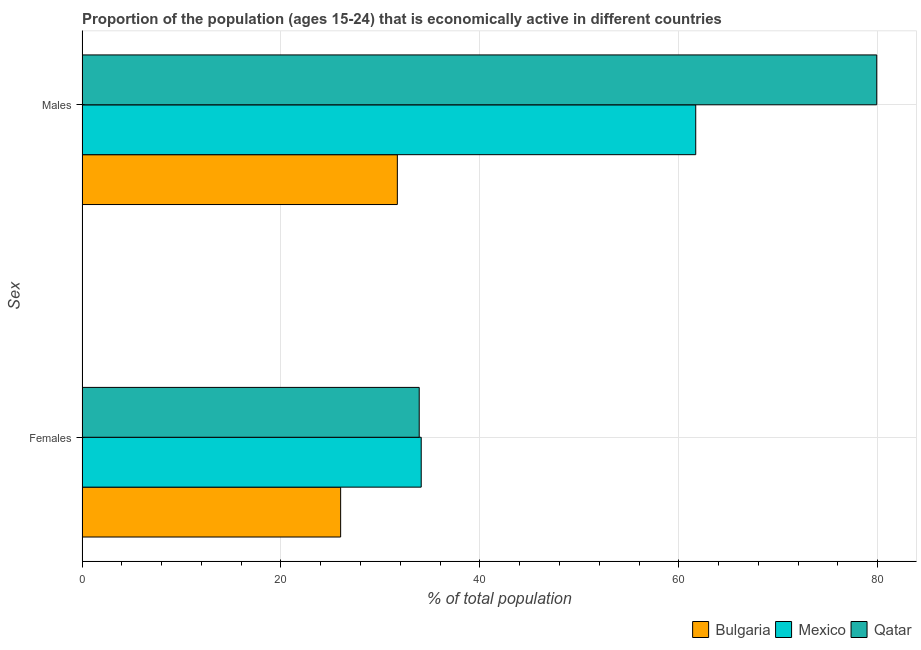How many groups of bars are there?
Give a very brief answer. 2. Are the number of bars on each tick of the Y-axis equal?
Offer a very short reply. Yes. What is the label of the 1st group of bars from the top?
Your response must be concise. Males. What is the percentage of economically active male population in Bulgaria?
Provide a short and direct response. 31.7. Across all countries, what is the maximum percentage of economically active female population?
Your answer should be very brief. 34.1. In which country was the percentage of economically active male population maximum?
Give a very brief answer. Qatar. In which country was the percentage of economically active male population minimum?
Your answer should be very brief. Bulgaria. What is the total percentage of economically active male population in the graph?
Your answer should be very brief. 173.3. What is the difference between the percentage of economically active female population in Bulgaria and that in Mexico?
Make the answer very short. -8.1. What is the difference between the percentage of economically active female population in Qatar and the percentage of economically active male population in Mexico?
Your answer should be compact. -27.8. What is the average percentage of economically active male population per country?
Keep it short and to the point. 57.77. What is the difference between the percentage of economically active female population and percentage of economically active male population in Bulgaria?
Provide a succinct answer. -5.7. What is the ratio of the percentage of economically active male population in Qatar to that in Mexico?
Ensure brevity in your answer.  1.29. What does the 2nd bar from the top in Females represents?
Make the answer very short. Mexico. What does the 3rd bar from the bottom in Males represents?
Give a very brief answer. Qatar. How many bars are there?
Your answer should be compact. 6. Are the values on the major ticks of X-axis written in scientific E-notation?
Keep it short and to the point. No. Does the graph contain any zero values?
Your answer should be compact. No. Does the graph contain grids?
Your answer should be compact. Yes. What is the title of the graph?
Offer a very short reply. Proportion of the population (ages 15-24) that is economically active in different countries. Does "St. Kitts and Nevis" appear as one of the legend labels in the graph?
Offer a very short reply. No. What is the label or title of the X-axis?
Offer a terse response. % of total population. What is the label or title of the Y-axis?
Your answer should be very brief. Sex. What is the % of total population in Bulgaria in Females?
Ensure brevity in your answer.  26. What is the % of total population of Mexico in Females?
Your answer should be compact. 34.1. What is the % of total population of Qatar in Females?
Keep it short and to the point. 33.9. What is the % of total population of Bulgaria in Males?
Ensure brevity in your answer.  31.7. What is the % of total population of Mexico in Males?
Provide a succinct answer. 61.7. What is the % of total population of Qatar in Males?
Make the answer very short. 79.9. Across all Sex, what is the maximum % of total population of Bulgaria?
Provide a short and direct response. 31.7. Across all Sex, what is the maximum % of total population in Mexico?
Your answer should be very brief. 61.7. Across all Sex, what is the maximum % of total population in Qatar?
Offer a very short reply. 79.9. Across all Sex, what is the minimum % of total population of Mexico?
Offer a very short reply. 34.1. Across all Sex, what is the minimum % of total population in Qatar?
Your answer should be compact. 33.9. What is the total % of total population of Bulgaria in the graph?
Make the answer very short. 57.7. What is the total % of total population of Mexico in the graph?
Offer a terse response. 95.8. What is the total % of total population of Qatar in the graph?
Offer a very short reply. 113.8. What is the difference between the % of total population of Mexico in Females and that in Males?
Offer a terse response. -27.6. What is the difference between the % of total population in Qatar in Females and that in Males?
Give a very brief answer. -46. What is the difference between the % of total population of Bulgaria in Females and the % of total population of Mexico in Males?
Your answer should be compact. -35.7. What is the difference between the % of total population in Bulgaria in Females and the % of total population in Qatar in Males?
Provide a short and direct response. -53.9. What is the difference between the % of total population of Mexico in Females and the % of total population of Qatar in Males?
Provide a succinct answer. -45.8. What is the average % of total population of Bulgaria per Sex?
Offer a terse response. 28.85. What is the average % of total population in Mexico per Sex?
Provide a succinct answer. 47.9. What is the average % of total population of Qatar per Sex?
Provide a short and direct response. 56.9. What is the difference between the % of total population of Bulgaria and % of total population of Mexico in Females?
Make the answer very short. -8.1. What is the difference between the % of total population in Bulgaria and % of total population in Qatar in Females?
Give a very brief answer. -7.9. What is the difference between the % of total population of Mexico and % of total population of Qatar in Females?
Offer a very short reply. 0.2. What is the difference between the % of total population of Bulgaria and % of total population of Qatar in Males?
Give a very brief answer. -48.2. What is the difference between the % of total population in Mexico and % of total population in Qatar in Males?
Offer a terse response. -18.2. What is the ratio of the % of total population of Bulgaria in Females to that in Males?
Your answer should be compact. 0.82. What is the ratio of the % of total population of Mexico in Females to that in Males?
Give a very brief answer. 0.55. What is the ratio of the % of total population of Qatar in Females to that in Males?
Ensure brevity in your answer.  0.42. What is the difference between the highest and the second highest % of total population in Mexico?
Your answer should be very brief. 27.6. What is the difference between the highest and the lowest % of total population in Bulgaria?
Keep it short and to the point. 5.7. What is the difference between the highest and the lowest % of total population in Mexico?
Offer a very short reply. 27.6. 